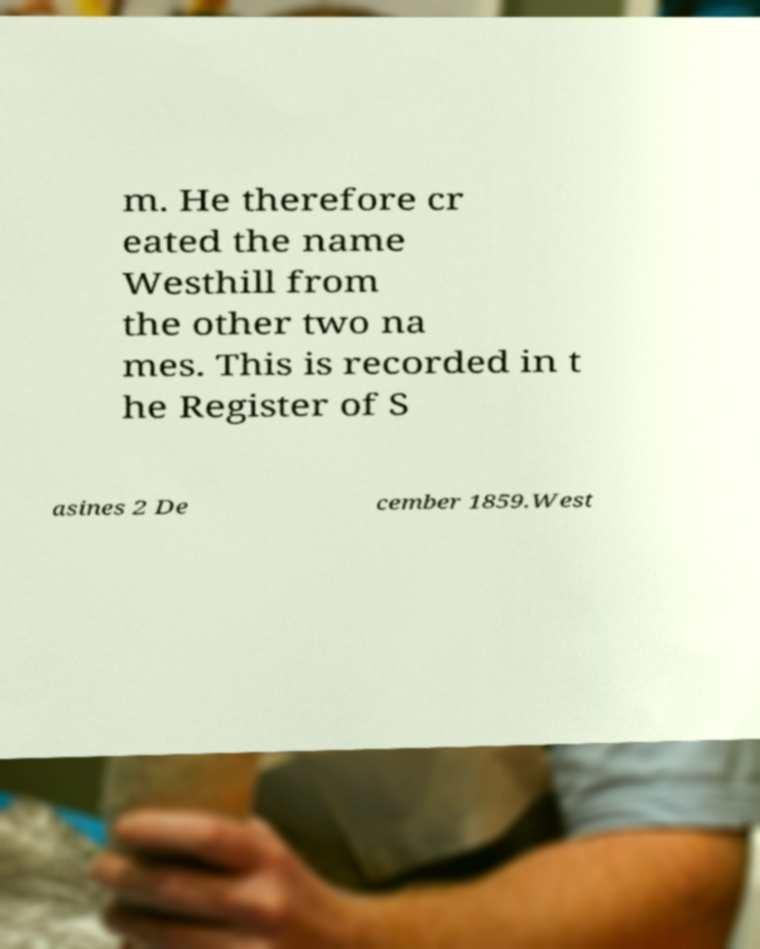I need the written content from this picture converted into text. Can you do that? m. He therefore cr eated the name Westhill from the other two na mes. This is recorded in t he Register of S asines 2 De cember 1859.West 